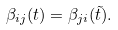<formula> <loc_0><loc_0><loc_500><loc_500>\beta _ { i j } ( t ) = \beta _ { j i } ( \tilde { t } ) .</formula> 